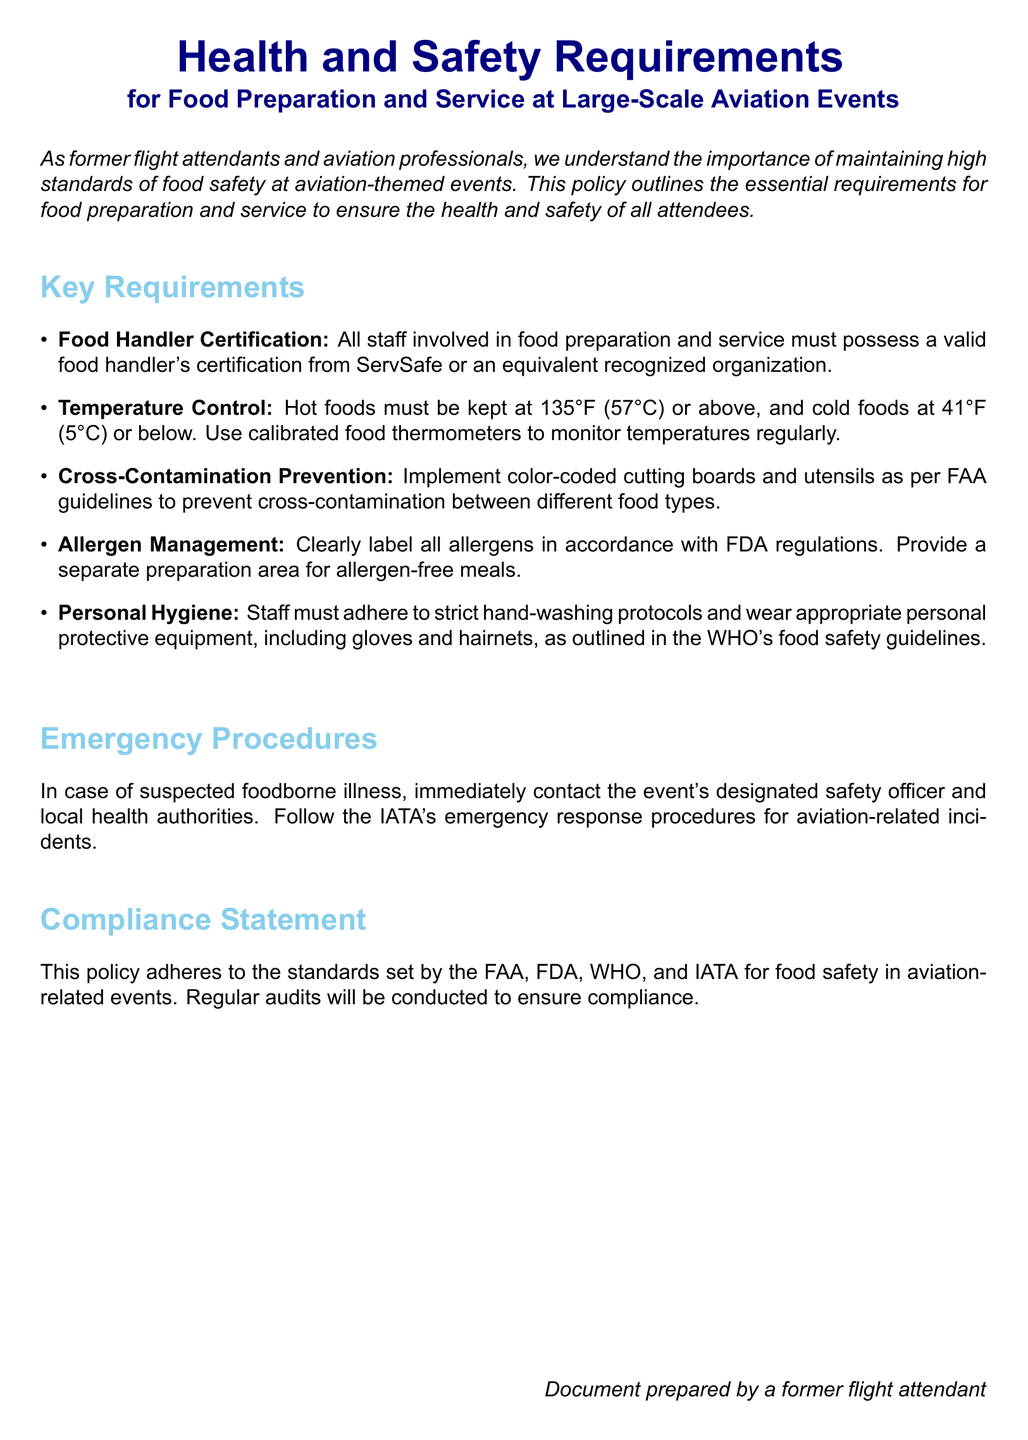What is the document's title? The title of the document is located at the beginning, explaining the focus on health and safety in food preparation and service for aviation events.
Answer: Health and Safety Requirements What certification must food handlers possess? The document specifies that food handlers must have a valid food handler's certification from ServSafe or an equivalent organization.
Answer: Food Handler Certification What temperature must hot foods be kept at? The document states that hot foods must be kept at a minimum temperature to ensure safety during food service.
Answer: 135°F (57°C) Which organization's guidelines are referenced for cross-contamination prevention? One of the key requirements mentions guidelines for preventing cross-contamination from a specific authority in aviation.
Answer: FAA What should staff do in case of suspected foodborne illness? The document outlines the steps the staff should follow regarding reporting any foodborne illness suspected during the event.
Answer: Contact the designated safety officer What type of equipment must staff wear? The document details the personal protective equipment that is required for staff to maintain hygiene during food preparation and service.
Answer: Gloves and hairnets What is the main focus of this policy document? The document clearly mentions that it is dedicated to ensuring health and safety standards specifically for food-related operations in aviation settings.
Answer: Food safety at aviation-themed events What will be conducted to ensure compliance with safety standards? The document states that regular checks or assessments will be performed to ensure that the safety practices are followed as per established guidelines.
Answer: Regular audits 